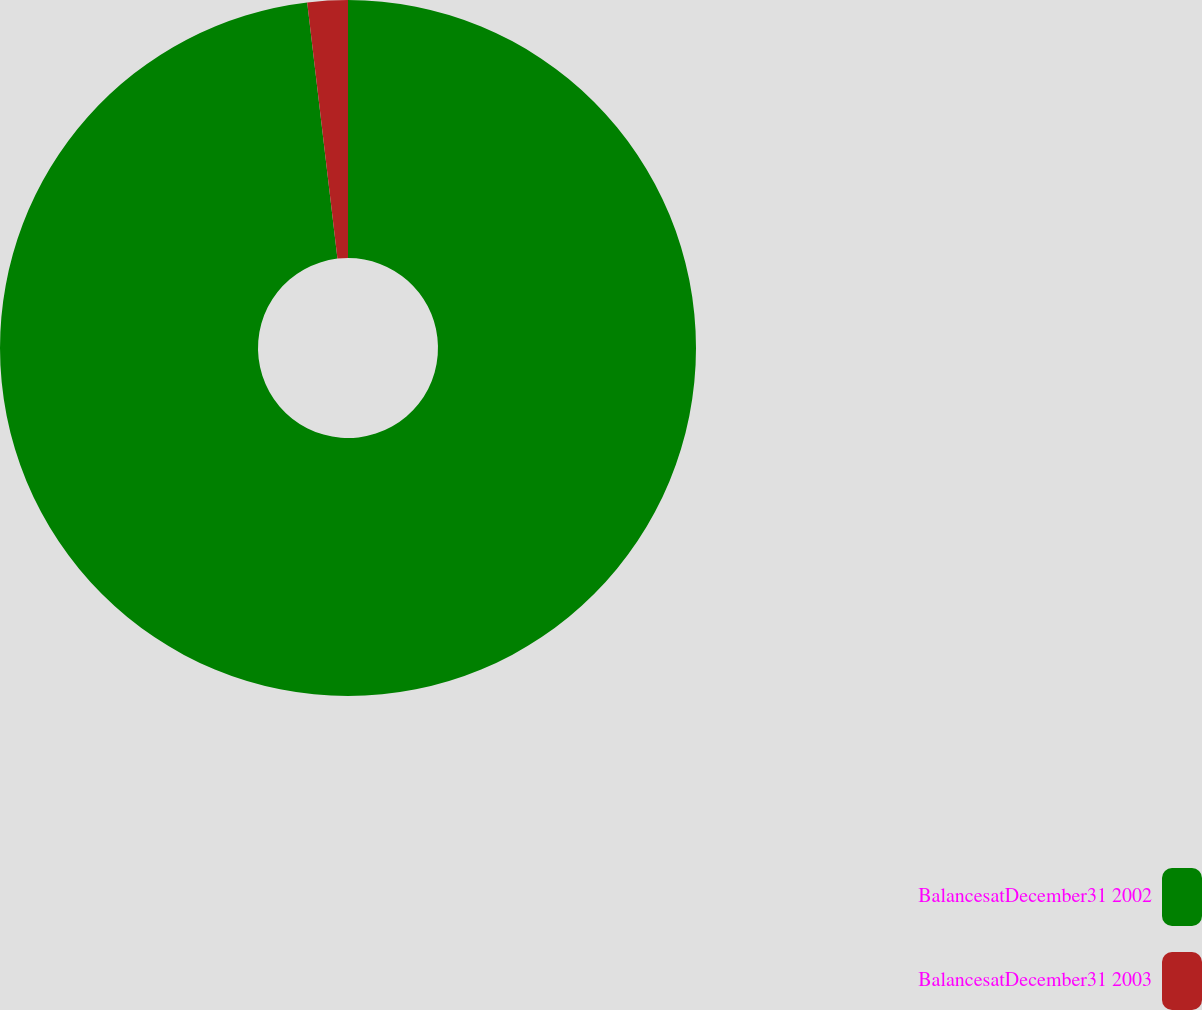<chart> <loc_0><loc_0><loc_500><loc_500><pie_chart><fcel>BalancesatDecember31 2002<fcel>BalancesatDecember31 2003<nl><fcel>98.13%<fcel>1.87%<nl></chart> 